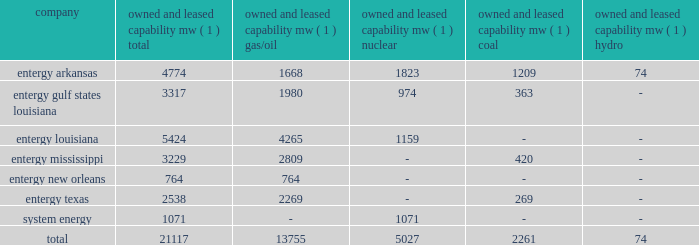Part i item 1 entergy corporation , utility operating companies , and system energy entergy new orleans provides electric and gas service in the city of new orleans pursuant to indeterminate permits set forth in city ordinances ( except electric service in algiers , which is provided by entergy louisiana ) .
These ordinances contain a continuing option for the city of new orleans to purchase entergy new orleans 2019s electric and gas utility properties .
Entergy texas holds a certificate of convenience and necessity from the puct to provide electric service to areas within approximately 27 counties in eastern texas , and holds non-exclusive franchises to provide electric service in approximately 68 incorporated municipalities .
Entergy texas was typically granted 50-year franchises , but recently has been receiving 25-year franchises .
Entergy texas 2019s electric franchises expire during 2013-2058 .
The business of system energy is limited to wholesale power sales .
It has no distribution franchises .
Property and other generation resources generating stations the total capability of the generating stations owned and leased by the utility operating companies and system energy as of december 31 , 2011 , is indicated below: .
( 1 ) 201cowned and leased capability 201d is the dependable load carrying capability as demonstrated under actual operating conditions based on the primary fuel ( assuming no curtailments ) that each station was designed to utilize .
The entergy system's load and capacity projections are reviewed periodically to assess the need and timing for additional generating capacity and interconnections .
These reviews consider existing and projected demand , the availability and price of power , the location of new load , and the economy .
Summer peak load in the entergy system service territory has averaged 21246 mw from 2002-2011 .
In the 2002 time period , the entergy system's long-term capacity resources , allowing for an adequate reserve margin , were approximately 3000 mw less than the total capacity required for peak period demands .
In this time period the entergy system met its capacity shortages almost entirely through short-term power purchases in the wholesale spot market .
In the fall of 2002 , the entergy system began a program to add new resources to its existing generation portfolio and began a process of issuing requests for proposals ( rfp ) to procure supply-side resources from sources other than the spot market to meet the unique regional needs of the utility operating companies .
The entergy system has adopted a long-term resource strategy that calls for the bulk of capacity needs to be met through long-term resources , whether owned or contracted .
Entergy refers to this strategy as the "portfolio transformation strategy" .
Over the past nine years , portfolio transformation has resulted in the addition of about 4500 mw of new long-term resources .
These figures do not include transactions currently pending as a result of the summer 2009 rfp .
When the summer 2009 rfp transactions are included in the entergy system portfolio of long-term resources and adjusting for unit deactivations of older generation , the entergy system is approximately 500 mw short of its projected 2012 peak load plus reserve margin .
This remaining need is expected to be met through a nuclear uprate at grand gulf and limited-term resources .
The entergy system will continue to access the spot power market to economically .
In 2011 what was the ratio of the entergy arkansas property and other generation resources generating capacity of nuclear to hydro? 
Computations: (1823 / 74)
Answer: 24.63514. 